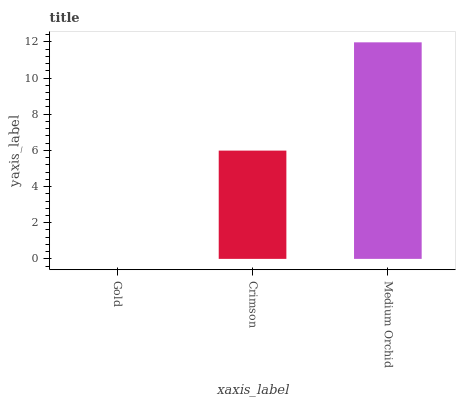Is Gold the minimum?
Answer yes or no. Yes. Is Medium Orchid the maximum?
Answer yes or no. Yes. Is Crimson the minimum?
Answer yes or no. No. Is Crimson the maximum?
Answer yes or no. No. Is Crimson greater than Gold?
Answer yes or no. Yes. Is Gold less than Crimson?
Answer yes or no. Yes. Is Gold greater than Crimson?
Answer yes or no. No. Is Crimson less than Gold?
Answer yes or no. No. Is Crimson the high median?
Answer yes or no. Yes. Is Crimson the low median?
Answer yes or no. Yes. Is Gold the high median?
Answer yes or no. No. Is Gold the low median?
Answer yes or no. No. 